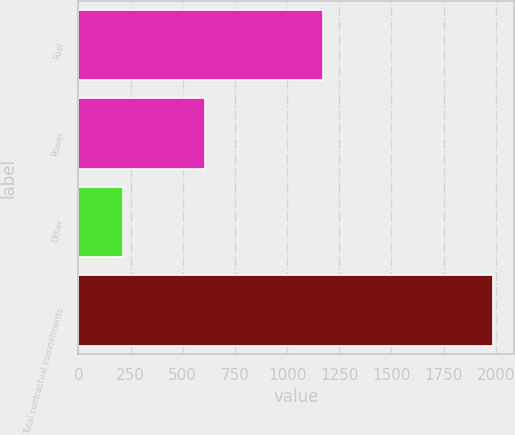<chart> <loc_0><loc_0><loc_500><loc_500><bar_chart><fcel>Fuel<fcel>Power<fcel>Other<fcel>Total contractual commitments<nl><fcel>1169.9<fcel>604.2<fcel>213.3<fcel>1987.4<nl></chart> 